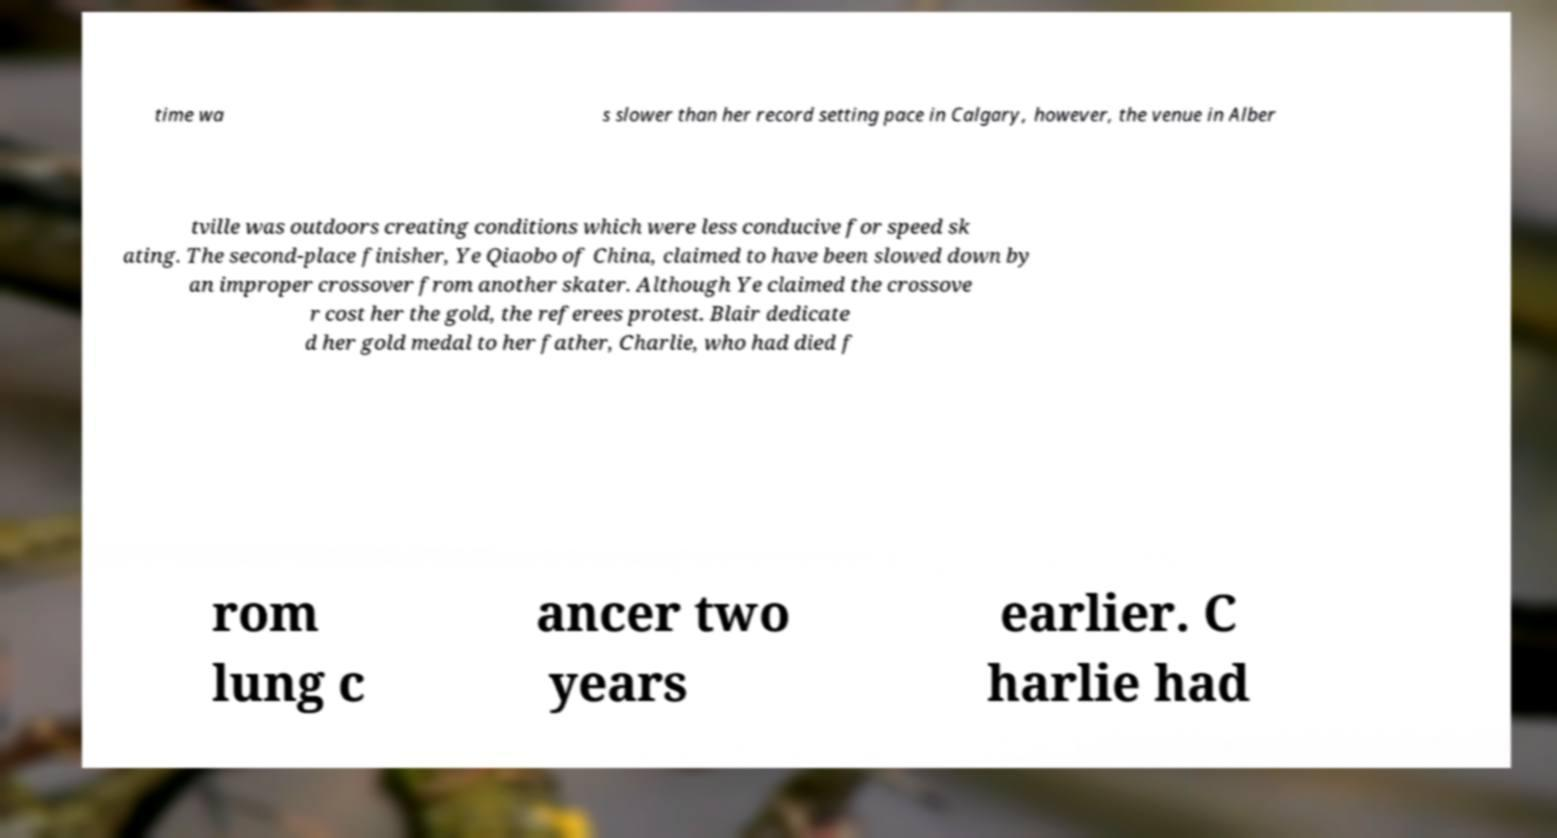Please identify and transcribe the text found in this image. time wa s slower than her record setting pace in Calgary, however, the venue in Alber tville was outdoors creating conditions which were less conducive for speed sk ating. The second-place finisher, Ye Qiaobo of China, claimed to have been slowed down by an improper crossover from another skater. Although Ye claimed the crossove r cost her the gold, the referees protest. Blair dedicate d her gold medal to her father, Charlie, who had died f rom lung c ancer two years earlier. C harlie had 